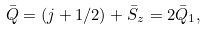<formula> <loc_0><loc_0><loc_500><loc_500>\bar { Q } = ( j + 1 / 2 ) + \bar { S } _ { z } = 2 \bar { Q } _ { 1 } ,</formula> 